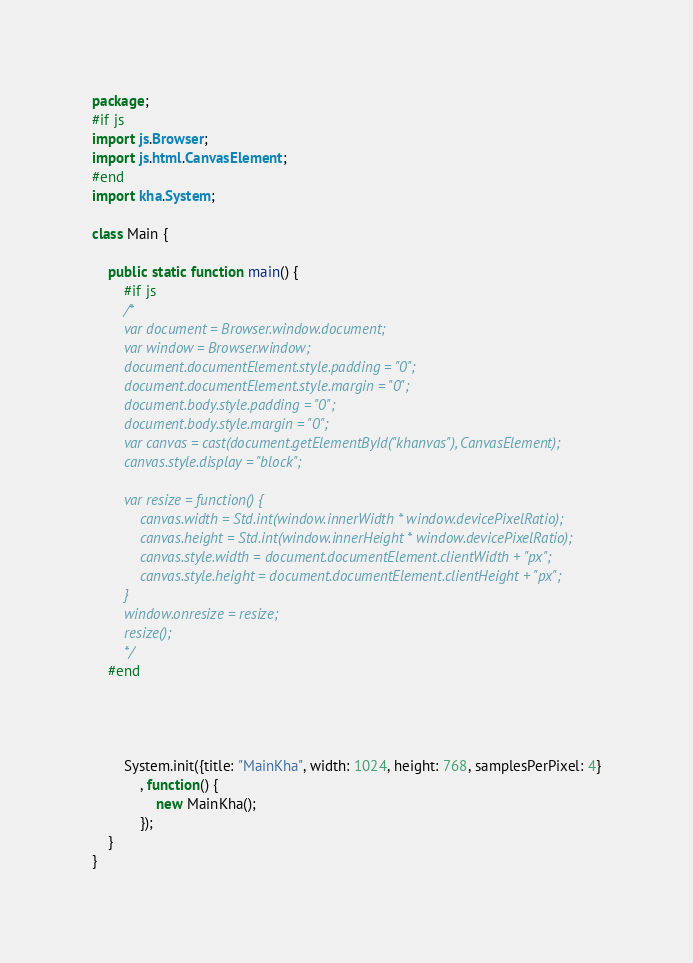Convert code to text. <code><loc_0><loc_0><loc_500><loc_500><_Haxe_>package;
#if js
import js.Browser;
import js.html.CanvasElement;
#end
import kha.System;

class Main {
	
	public static function main() {
		#if js
		/*
		var document = Browser.window.document;
		var window = Browser.window;
		document.documentElement.style.padding = "0";
		document.documentElement.style.margin = "0";
		document.body.style.padding = "0";
		document.body.style.margin = "0";
		var canvas = cast(document.getElementById("khanvas"), CanvasElement);
		canvas.style.display = "block";
		
		var resize = function() {
			canvas.width = Std.int(window.innerWidth * window.devicePixelRatio);
			canvas.height = Std.int(window.innerHeight * window.devicePixelRatio);
			canvas.style.width = document.documentElement.clientWidth + "px";
			canvas.style.height = document.documentElement.clientHeight + "px";
		}
		window.onresize = resize;
		resize();
		*/
	#end
	



		System.init({title: "MainKha", width: 1024, height: 768, samplesPerPixel: 4}
			, function() {
				new MainKha();
			});
	}
}</code> 